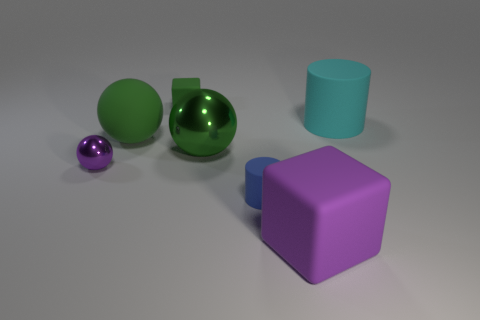There is a tiny rubber thing that is the same color as the big metal thing; what is its shape?
Provide a succinct answer. Cube. What number of large green things are the same material as the tiny sphere?
Your answer should be compact. 1. There is a green object that is in front of the large matte object that is on the left side of the rubber cube that is behind the large cyan rubber thing; what is its material?
Provide a succinct answer. Metal. What is the color of the metal ball that is left of the green block that is behind the tiny purple ball?
Provide a succinct answer. Purple. There is a block that is the same size as the green matte ball; what is its color?
Your answer should be very brief. Purple. How many small objects are green balls or blue cylinders?
Provide a short and direct response. 1. Is the number of small green blocks right of the big shiny thing greater than the number of tiny blue cylinders that are to the left of the large green rubber sphere?
Provide a succinct answer. No. What size is the matte block that is the same color as the big metallic sphere?
Your answer should be compact. Small. What number of other things are the same size as the blue cylinder?
Give a very brief answer. 2. Do the cube that is right of the green block and the tiny green block have the same material?
Your answer should be compact. Yes. 